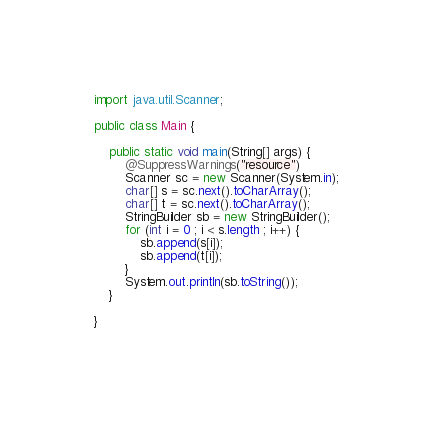Convert code to text. <code><loc_0><loc_0><loc_500><loc_500><_Java_>import java.util.Scanner;

public class Main {

    public static void main(String[] args) {
        @SuppressWarnings("resource")
        Scanner sc = new Scanner(System.in);
        char[] s = sc.next().toCharArray();
        char[] t = sc.next().toCharArray();
        StringBuilder sb = new StringBuilder();
        for (int i = 0 ; i < s.length ; i++) {
            sb.append(s[i]);
            sb.append(t[i]);
        }
        System.out.println(sb.toString());
    }

}
</code> 